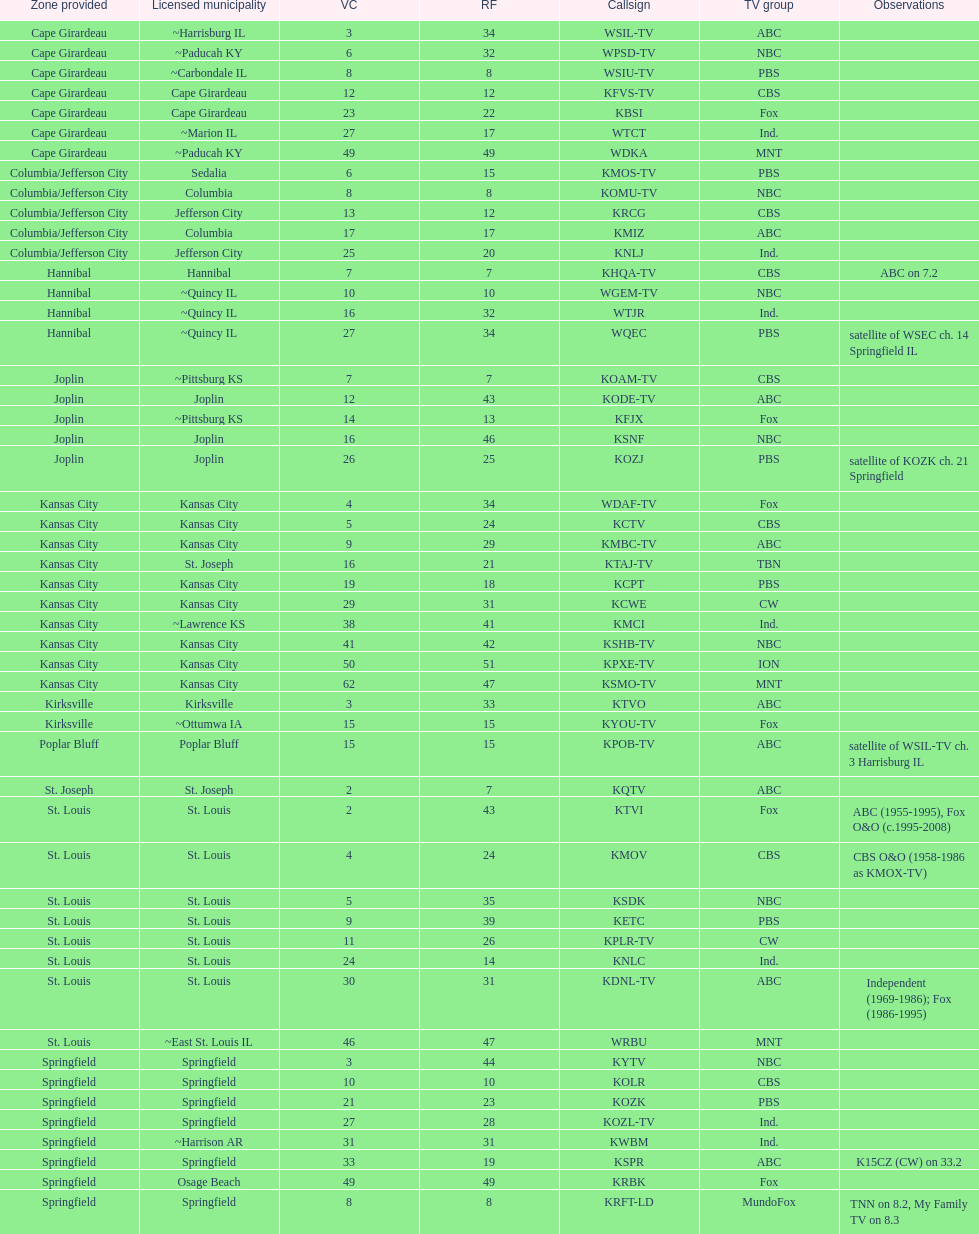What is the total number of cbs stations? 7. 